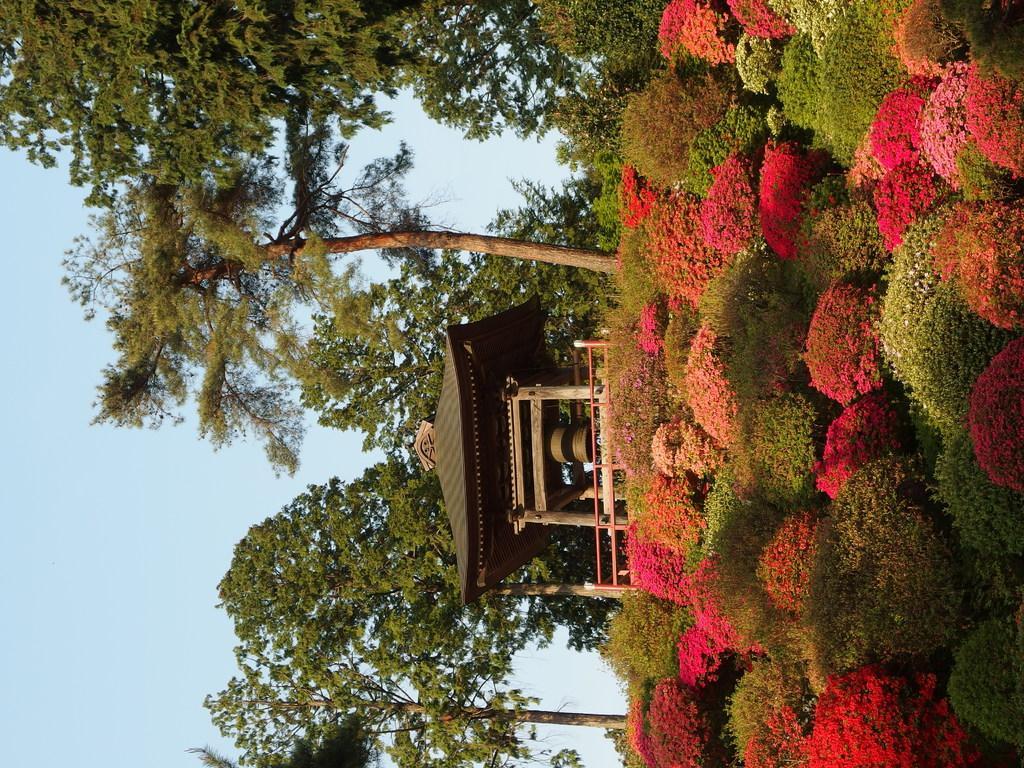Please provide a concise description of this image. To the right corner of the image there are many plants with pink and red flowers. In the middle of the image there is a hit with roof. And in the background there are trees and to the left corner of the image there is a sky. 